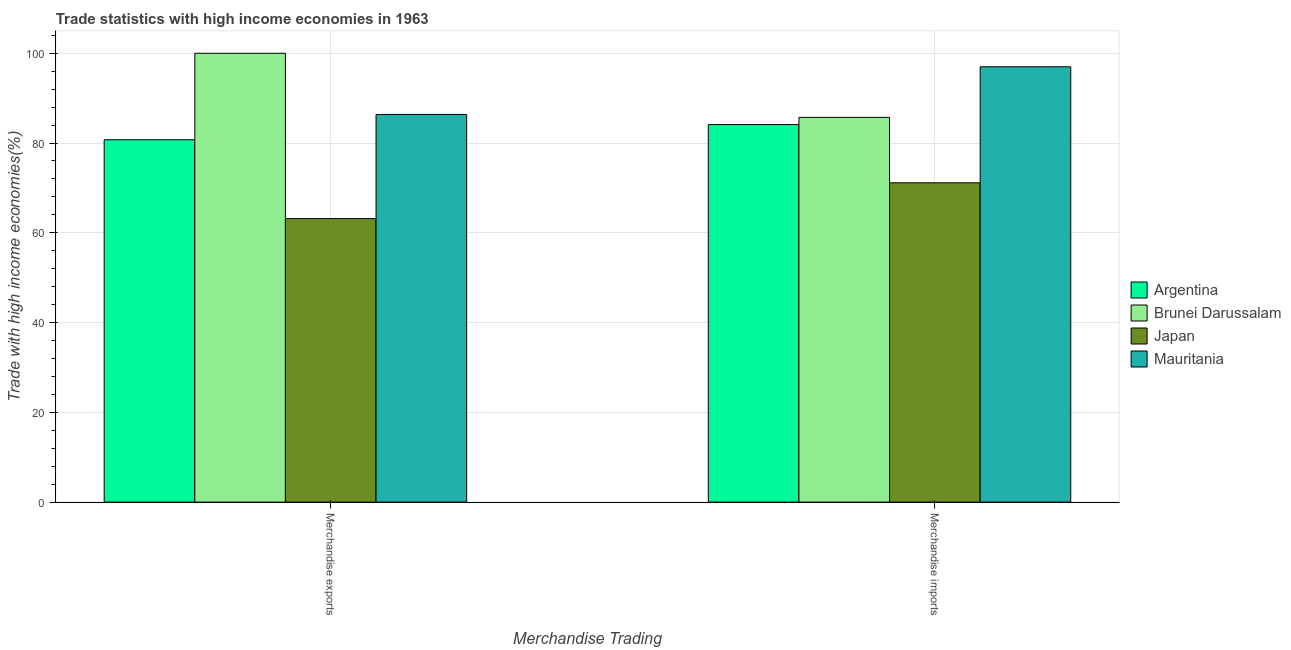How many different coloured bars are there?
Offer a terse response. 4. How many groups of bars are there?
Provide a succinct answer. 2. Are the number of bars per tick equal to the number of legend labels?
Keep it short and to the point. Yes. Are the number of bars on each tick of the X-axis equal?
Your answer should be very brief. Yes. How many bars are there on the 2nd tick from the left?
Your answer should be compact. 4. How many bars are there on the 2nd tick from the right?
Provide a short and direct response. 4. What is the label of the 1st group of bars from the left?
Your answer should be compact. Merchandise exports. What is the merchandise exports in Japan?
Provide a succinct answer. 63.17. Across all countries, what is the maximum merchandise imports?
Offer a very short reply. 96.99. Across all countries, what is the minimum merchandise exports?
Offer a very short reply. 63.17. In which country was the merchandise imports maximum?
Offer a terse response. Mauritania. What is the total merchandise exports in the graph?
Your answer should be very brief. 330.27. What is the difference between the merchandise exports in Mauritania and that in Argentina?
Your answer should be very brief. 5.63. What is the difference between the merchandise exports in Argentina and the merchandise imports in Japan?
Your answer should be compact. 9.59. What is the average merchandise imports per country?
Offer a very short reply. 84.49. What is the difference between the merchandise imports and merchandise exports in Argentina?
Provide a succinct answer. 3.38. What is the ratio of the merchandise imports in Japan to that in Mauritania?
Your response must be concise. 0.73. In how many countries, is the merchandise exports greater than the average merchandise exports taken over all countries?
Your answer should be compact. 2. What does the 4th bar from the right in Merchandise exports represents?
Your response must be concise. Argentina. How many bars are there?
Offer a terse response. 8. How many countries are there in the graph?
Your answer should be very brief. 4. Are the values on the major ticks of Y-axis written in scientific E-notation?
Your response must be concise. No. Does the graph contain grids?
Your response must be concise. Yes. Where does the legend appear in the graph?
Provide a succinct answer. Center right. How many legend labels are there?
Your answer should be very brief. 4. How are the legend labels stacked?
Make the answer very short. Vertical. What is the title of the graph?
Provide a short and direct response. Trade statistics with high income economies in 1963. What is the label or title of the X-axis?
Give a very brief answer. Merchandise Trading. What is the label or title of the Y-axis?
Your response must be concise. Trade with high income economies(%). What is the Trade with high income economies(%) of Argentina in Merchandise exports?
Keep it short and to the point. 80.73. What is the Trade with high income economies(%) in Brunei Darussalam in Merchandise exports?
Provide a short and direct response. 100. What is the Trade with high income economies(%) in Japan in Merchandise exports?
Offer a very short reply. 63.17. What is the Trade with high income economies(%) in Mauritania in Merchandise exports?
Keep it short and to the point. 86.36. What is the Trade with high income economies(%) in Argentina in Merchandise imports?
Make the answer very short. 84.11. What is the Trade with high income economies(%) of Brunei Darussalam in Merchandise imports?
Ensure brevity in your answer.  85.71. What is the Trade with high income economies(%) of Japan in Merchandise imports?
Your response must be concise. 71.14. What is the Trade with high income economies(%) of Mauritania in Merchandise imports?
Provide a succinct answer. 96.99. Across all Merchandise Trading, what is the maximum Trade with high income economies(%) in Argentina?
Offer a very short reply. 84.11. Across all Merchandise Trading, what is the maximum Trade with high income economies(%) of Japan?
Offer a terse response. 71.14. Across all Merchandise Trading, what is the maximum Trade with high income economies(%) of Mauritania?
Provide a succinct answer. 96.99. Across all Merchandise Trading, what is the minimum Trade with high income economies(%) in Argentina?
Give a very brief answer. 80.73. Across all Merchandise Trading, what is the minimum Trade with high income economies(%) in Brunei Darussalam?
Ensure brevity in your answer.  85.71. Across all Merchandise Trading, what is the minimum Trade with high income economies(%) of Japan?
Offer a terse response. 63.17. Across all Merchandise Trading, what is the minimum Trade with high income economies(%) of Mauritania?
Offer a very short reply. 86.36. What is the total Trade with high income economies(%) of Argentina in the graph?
Offer a terse response. 164.84. What is the total Trade with high income economies(%) of Brunei Darussalam in the graph?
Your answer should be compact. 185.71. What is the total Trade with high income economies(%) in Japan in the graph?
Your response must be concise. 134.32. What is the total Trade with high income economies(%) of Mauritania in the graph?
Offer a terse response. 183.35. What is the difference between the Trade with high income economies(%) of Argentina in Merchandise exports and that in Merchandise imports?
Provide a succinct answer. -3.38. What is the difference between the Trade with high income economies(%) in Brunei Darussalam in Merchandise exports and that in Merchandise imports?
Keep it short and to the point. 14.29. What is the difference between the Trade with high income economies(%) in Japan in Merchandise exports and that in Merchandise imports?
Offer a terse response. -7.97. What is the difference between the Trade with high income economies(%) of Mauritania in Merchandise exports and that in Merchandise imports?
Make the answer very short. -10.63. What is the difference between the Trade with high income economies(%) of Argentina in Merchandise exports and the Trade with high income economies(%) of Brunei Darussalam in Merchandise imports?
Make the answer very short. -4.98. What is the difference between the Trade with high income economies(%) of Argentina in Merchandise exports and the Trade with high income economies(%) of Japan in Merchandise imports?
Your response must be concise. 9.59. What is the difference between the Trade with high income economies(%) of Argentina in Merchandise exports and the Trade with high income economies(%) of Mauritania in Merchandise imports?
Your response must be concise. -16.26. What is the difference between the Trade with high income economies(%) in Brunei Darussalam in Merchandise exports and the Trade with high income economies(%) in Japan in Merchandise imports?
Your answer should be very brief. 28.86. What is the difference between the Trade with high income economies(%) in Brunei Darussalam in Merchandise exports and the Trade with high income economies(%) in Mauritania in Merchandise imports?
Offer a terse response. 3.01. What is the difference between the Trade with high income economies(%) of Japan in Merchandise exports and the Trade with high income economies(%) of Mauritania in Merchandise imports?
Ensure brevity in your answer.  -33.82. What is the average Trade with high income economies(%) of Argentina per Merchandise Trading?
Provide a short and direct response. 82.42. What is the average Trade with high income economies(%) in Brunei Darussalam per Merchandise Trading?
Offer a very short reply. 92.86. What is the average Trade with high income economies(%) of Japan per Merchandise Trading?
Make the answer very short. 67.16. What is the average Trade with high income economies(%) of Mauritania per Merchandise Trading?
Offer a terse response. 91.68. What is the difference between the Trade with high income economies(%) of Argentina and Trade with high income economies(%) of Brunei Darussalam in Merchandise exports?
Your response must be concise. -19.27. What is the difference between the Trade with high income economies(%) of Argentina and Trade with high income economies(%) of Japan in Merchandise exports?
Provide a succinct answer. 17.56. What is the difference between the Trade with high income economies(%) in Argentina and Trade with high income economies(%) in Mauritania in Merchandise exports?
Give a very brief answer. -5.63. What is the difference between the Trade with high income economies(%) of Brunei Darussalam and Trade with high income economies(%) of Japan in Merchandise exports?
Provide a succinct answer. 36.83. What is the difference between the Trade with high income economies(%) in Brunei Darussalam and Trade with high income economies(%) in Mauritania in Merchandise exports?
Offer a very short reply. 13.64. What is the difference between the Trade with high income economies(%) in Japan and Trade with high income economies(%) in Mauritania in Merchandise exports?
Make the answer very short. -23.19. What is the difference between the Trade with high income economies(%) of Argentina and Trade with high income economies(%) of Brunei Darussalam in Merchandise imports?
Provide a short and direct response. -1.6. What is the difference between the Trade with high income economies(%) of Argentina and Trade with high income economies(%) of Japan in Merchandise imports?
Ensure brevity in your answer.  12.97. What is the difference between the Trade with high income economies(%) in Argentina and Trade with high income economies(%) in Mauritania in Merchandise imports?
Keep it short and to the point. -12.88. What is the difference between the Trade with high income economies(%) of Brunei Darussalam and Trade with high income economies(%) of Japan in Merchandise imports?
Give a very brief answer. 14.57. What is the difference between the Trade with high income economies(%) of Brunei Darussalam and Trade with high income economies(%) of Mauritania in Merchandise imports?
Your response must be concise. -11.28. What is the difference between the Trade with high income economies(%) of Japan and Trade with high income economies(%) of Mauritania in Merchandise imports?
Your answer should be very brief. -25.85. What is the ratio of the Trade with high income economies(%) of Argentina in Merchandise exports to that in Merchandise imports?
Make the answer very short. 0.96. What is the ratio of the Trade with high income economies(%) in Japan in Merchandise exports to that in Merchandise imports?
Make the answer very short. 0.89. What is the ratio of the Trade with high income economies(%) in Mauritania in Merchandise exports to that in Merchandise imports?
Ensure brevity in your answer.  0.89. What is the difference between the highest and the second highest Trade with high income economies(%) in Argentina?
Provide a short and direct response. 3.38. What is the difference between the highest and the second highest Trade with high income economies(%) of Brunei Darussalam?
Make the answer very short. 14.29. What is the difference between the highest and the second highest Trade with high income economies(%) of Japan?
Offer a terse response. 7.97. What is the difference between the highest and the second highest Trade with high income economies(%) in Mauritania?
Your response must be concise. 10.63. What is the difference between the highest and the lowest Trade with high income economies(%) in Argentina?
Your answer should be compact. 3.38. What is the difference between the highest and the lowest Trade with high income economies(%) of Brunei Darussalam?
Offer a very short reply. 14.29. What is the difference between the highest and the lowest Trade with high income economies(%) of Japan?
Give a very brief answer. 7.97. What is the difference between the highest and the lowest Trade with high income economies(%) of Mauritania?
Provide a short and direct response. 10.63. 